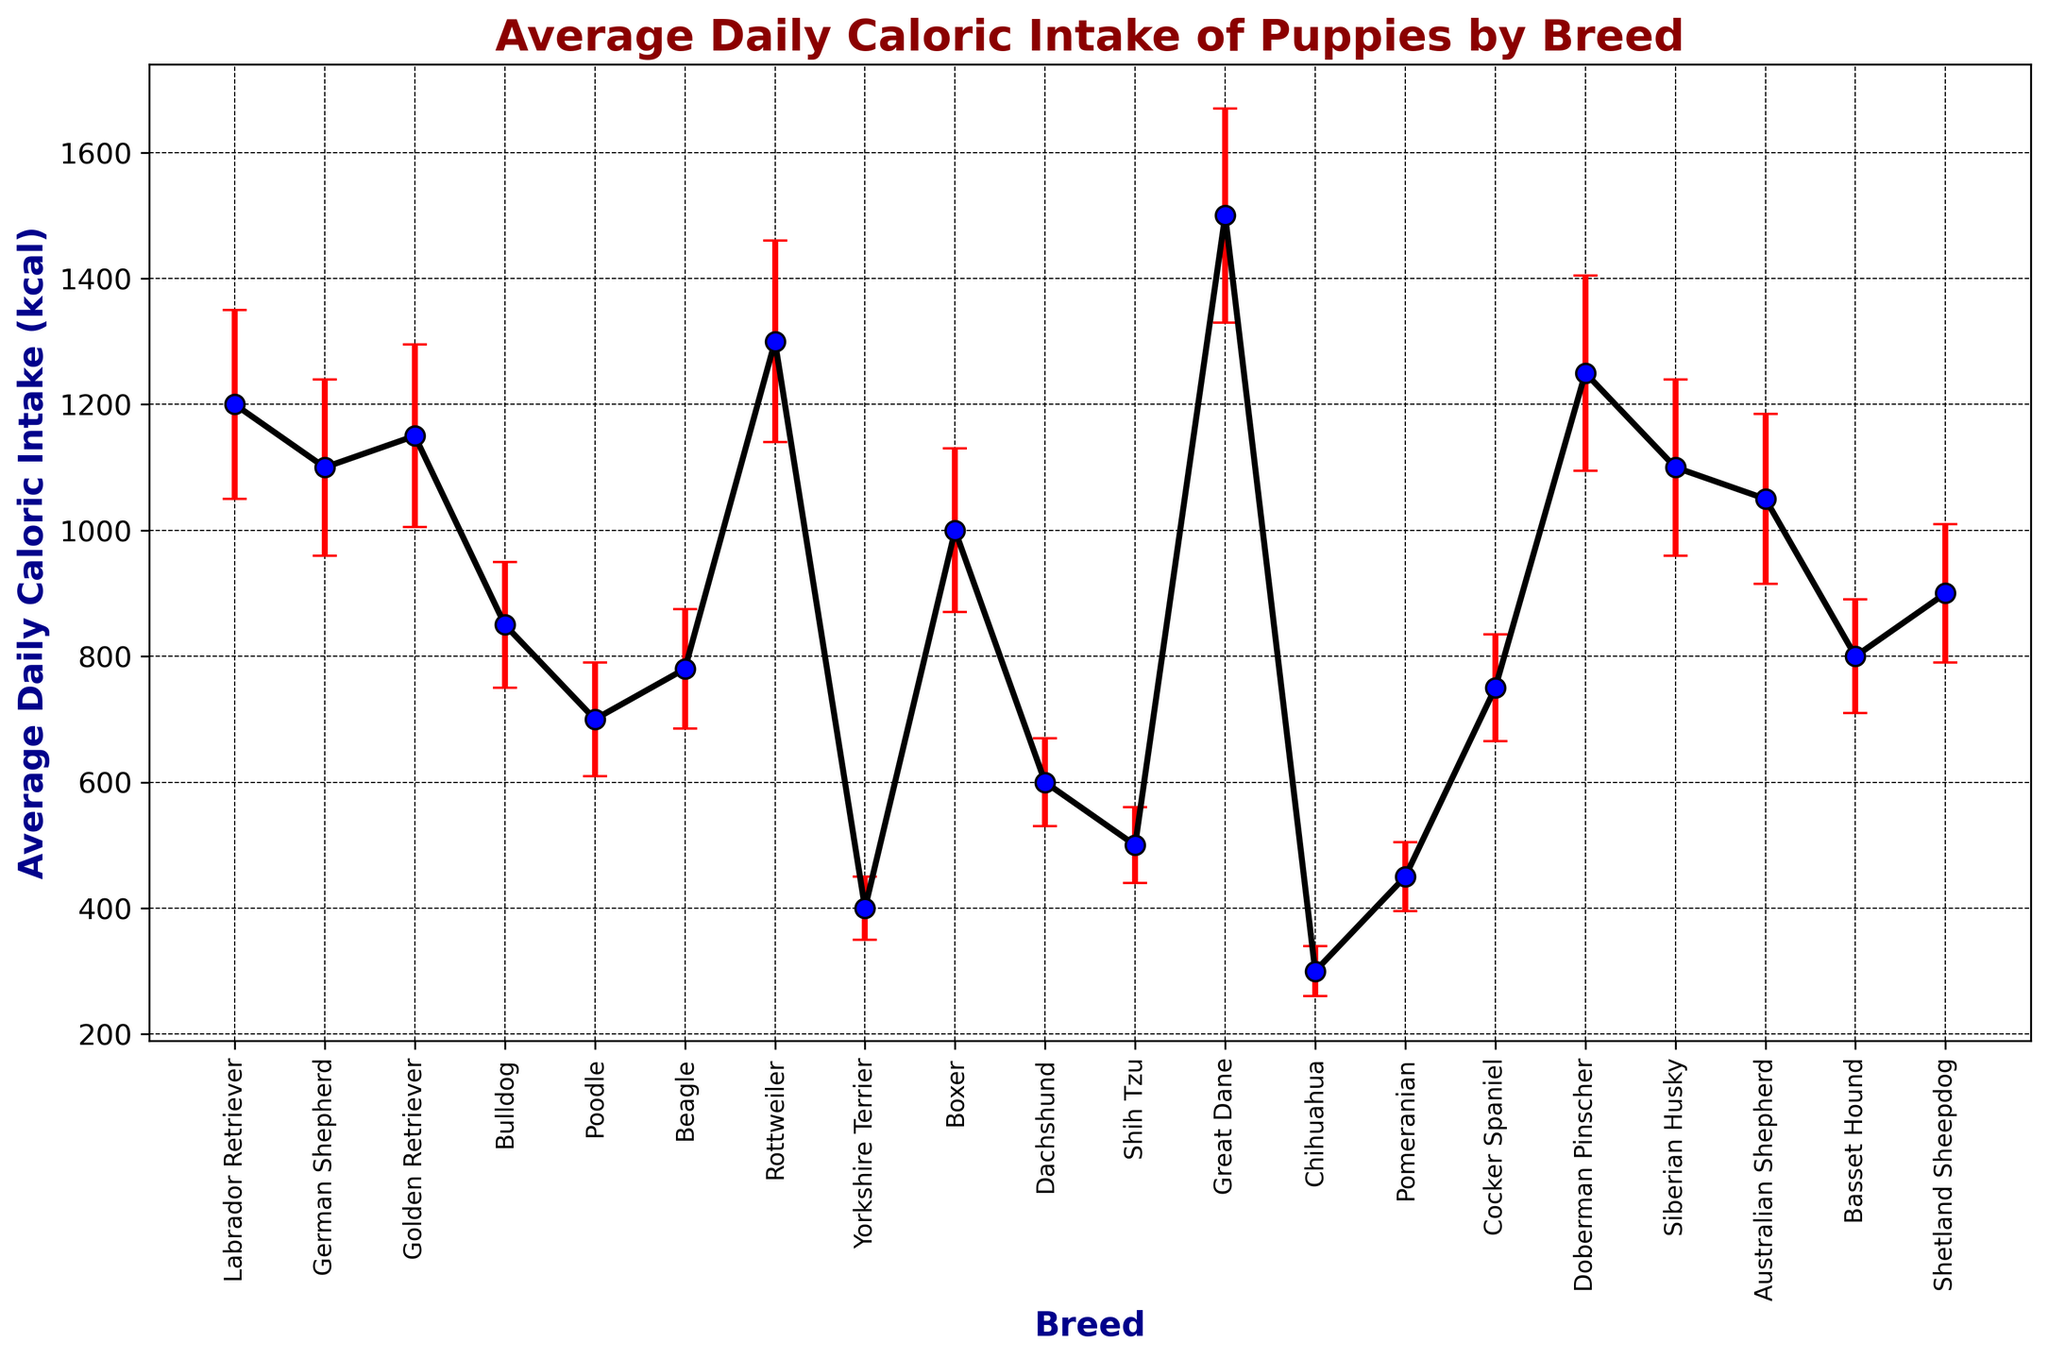What's the breed with the highest average daily caloric intake? By looking at the figure, identify the breed with the tallest marker (indicating the highest caloric intake). The Great Dane has the highest point.
Answer: Great Dane Which breed has the lowest average daily caloric intake? Look at the figure and find the breed with the shortest marker (indicating the lowest caloric intake). The Chihuahua has the lowest value.
Answer: Chihuahua What is the difference in average daily caloric intake between the Great Dane and the Chihuahua? Find the average daily caloric intake for both breeds in the figure: Great Dane (1500 kcal) and Chihuahua (300 kcal). Subtract the intake of the Chihuahua from that of the Great Dane: 1500 - 300 = 1200 kcal.
Answer: 1200 kcal Which breeds have an average daily caloric intake greater than 1000 kcal? Identify the markers that are above the 1000 kcal line. The breeds with markers above this line are Labrador Retriever, German Shepherd, Golden Retriever, Rottweiler, Boxer, Doberman Pinscher, Siberian Husky, and Great Dane.
Answer: Labrador Retriever, German Shepherd, Golden Retriever, Rottweiler, Doberman Pinscher, and Great Dane What is the average caloric intake between Beagle, Poodle, and Bulldog? Find the average daily caloric intake for Beagle (780 kcal), Poodle (700 kcal), and Bulldog (850 kcal). Sum these values and divide by 3: (780 + 700 + 850) / 3 = 2330 / 3 = ~776.67 kcal.
Answer: ~776.67 kcal How does the caloric intake of the Basset Hound compare to that of the Cocker Spaniel? By looking at the figure, note that the Basset Hound's marker (800 kcal) is slightly higher than that of the Cocker Spaniel (750 kcal).
Answer: Basset Hound > Cocker Spaniel What is the standard deviation for the caloric intake of the Rottweiler? Find the error bar length for the Rottweiler in the chart. Based on the data, the standard deviation is 160 kcal.
Answer: 160 kcal Which breed has the smallest standard deviation in daily caloric intake? Identify the breed with the shortest error bar. The Chihuahua has the shortest error bar, with a standard deviation of 40 kcal.
Answer: Chihuahua Are there any breeds with a standard deviation of 135 kcal? Look for breeds with error bars corresponding to 135 kcal. From the figure and data, the Australian Shepherd has a standard deviation of 135 kcal.
Answer: Australian Shepherd What is the average difference in daily caloric intake between the Labrador Retriever and the Shih Tzu? Identify the caloric intake values: Labrador Retriever (1200 kcal) and Shih Tzu (500 kcal). Calculate the difference: 1200 - 500 = 700 kcal. Since it's average, it results in the same 700 kcal as there are only two breeds being compared.
Answer: 700 kcal 